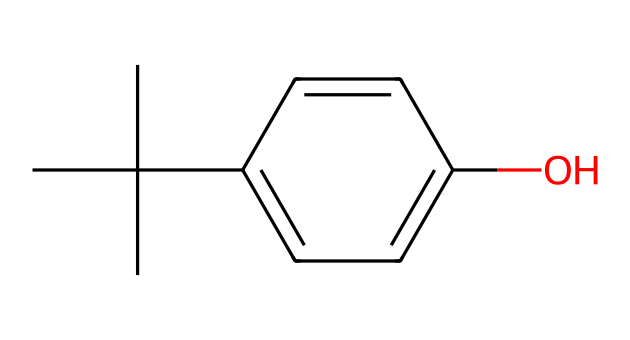What is the main functional group present in this chemical? The chemical contains a hydroxyl group (-OH), which is characteristic of phenols and indicates its main functional group.
Answer: hydroxyl group How many carbon atoms are present in the structure? By analyzing the SMILES representation, the structure has a total of 9 carbon atoms, including those in the aromatic ring and the branching aliphatic carbons.
Answer: 9 What is the molecular formula of this compound? Based on the carbon (C), hydrogen (H), and oxygen (O) atoms counted from the structure, the molecular formula can be derived as C12H16O.
Answer: C12H16O What type of antioxidant properties does this phenolic compound likely exhibit? Phenolic compounds are known for their ability to donate hydrogen atoms or electrons, which allows them to scavenge free radicals, thus providing antioxidant properties.
Answer: antioxidant How does the branched structure of this phenolic antioxidant impact its solubility? The branched structure can increase hydrophobic character, affecting solubility in polar solvents, typically reducing its solubility in water while increasing it in organic solvents.
Answer: reduces solubility in water What role do phenolic antioxidants play in food preservation? Phenolic antioxidants help prevent oxidation in food, which can lead to spoilage, therefore prolonging shelf-life and maintaining quality.
Answer: prolong shelf-life 